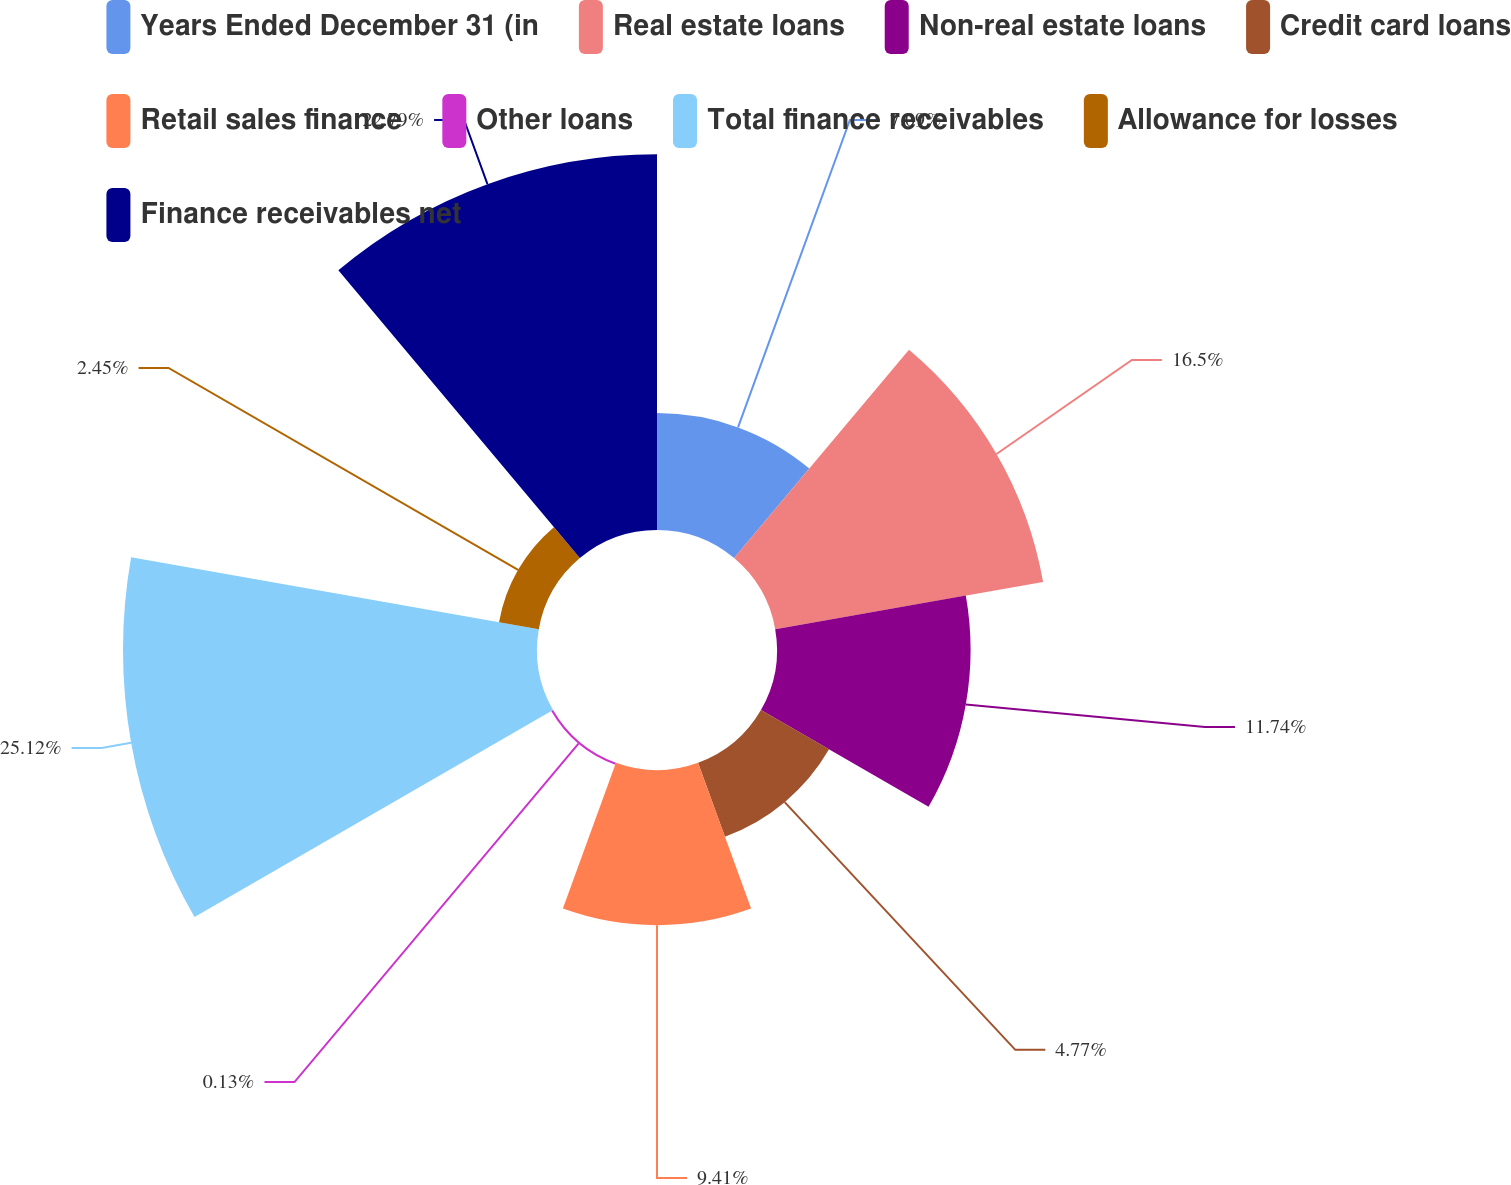Convert chart. <chart><loc_0><loc_0><loc_500><loc_500><pie_chart><fcel>Years Ended December 31 (in<fcel>Real estate loans<fcel>Non-real estate loans<fcel>Credit card loans<fcel>Retail sales finance<fcel>Other loans<fcel>Total finance receivables<fcel>Allowance for losses<fcel>Finance receivables net<nl><fcel>7.09%<fcel>16.5%<fcel>11.74%<fcel>4.77%<fcel>9.41%<fcel>0.13%<fcel>25.11%<fcel>2.45%<fcel>22.79%<nl></chart> 